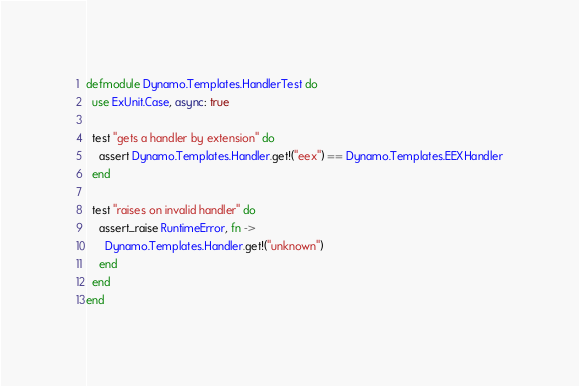<code> <loc_0><loc_0><loc_500><loc_500><_Elixir_>defmodule Dynamo.Templates.HandlerTest do
  use ExUnit.Case, async: true

  test "gets a handler by extension" do
    assert Dynamo.Templates.Handler.get!("eex") == Dynamo.Templates.EEXHandler
  end

  test "raises on invalid handler" do
    assert_raise RuntimeError, fn ->
      Dynamo.Templates.Handler.get!("unknown")
    end
  end
end</code> 